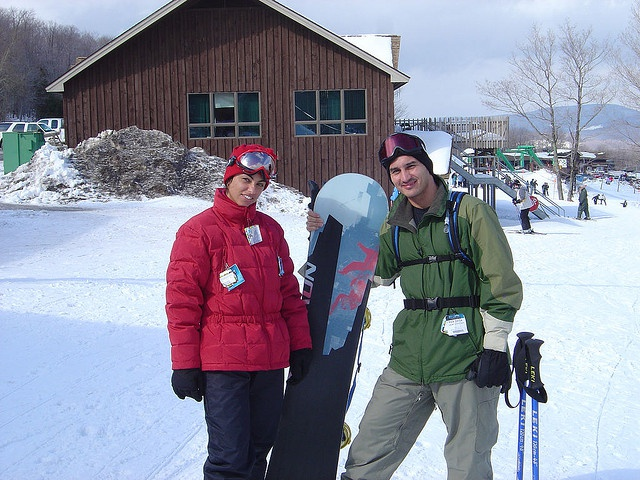Describe the objects in this image and their specific colors. I can see people in lavender, gray, black, and darkgreen tones, people in lavender, black, brown, and maroon tones, snowboard in lavender, black, gray, and lightblue tones, people in lavender, lightgray, darkgray, black, and gray tones, and car in lavender, white, gray, and blue tones in this image. 